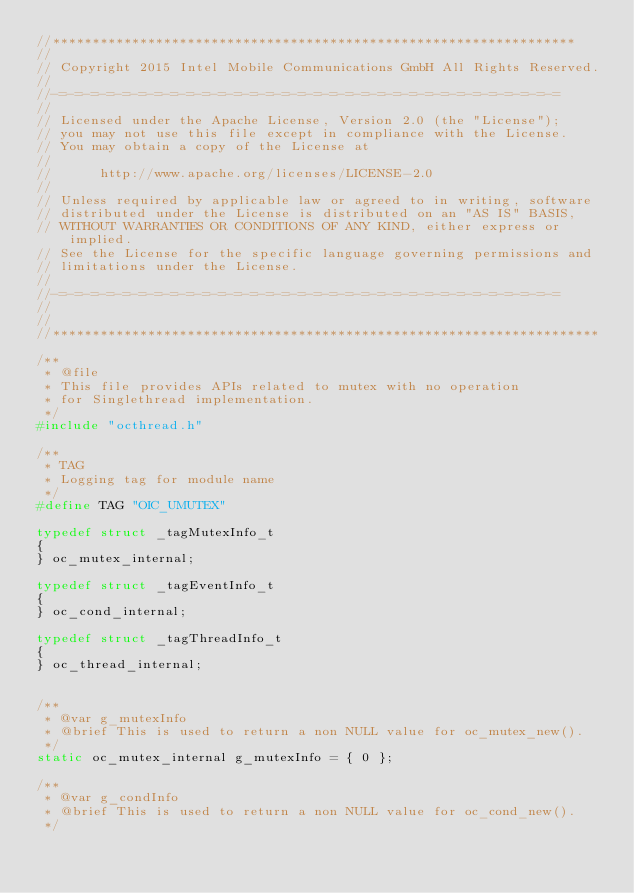Convert code to text. <code><loc_0><loc_0><loc_500><loc_500><_C_>//******************************************************************
//
// Copyright 2015 Intel Mobile Communications GmbH All Rights Reserved.
//
//-=-=-=-=-=-=-=-=-=-=-=-=-=-=-=-=-=-=-=-=-=-=-=-=-=-=-=-=-=-=-=-=
//
// Licensed under the Apache License, Version 2.0 (the "License");
// you may not use this file except in compliance with the License.
// You may obtain a copy of the License at
//
//      http://www.apache.org/licenses/LICENSE-2.0
//
// Unless required by applicable law or agreed to in writing, software
// distributed under the License is distributed on an "AS IS" BASIS,
// WITHOUT WARRANTIES OR CONDITIONS OF ANY KIND, either express or implied.
// See the License for the specific language governing permissions and
// limitations under the License.
//
//-=-=-=-=-=-=-=-=-=-=-=-=-=-=-=-=-=-=-=-=-=-=-=-=-=-=-=-=-=-=-=-=
//
//
//*********************************************************************

/**
 * @file
 * This file provides APIs related to mutex with no operation
 * for Singlethread implementation.
 */
#include "octhread.h"

/**
 * TAG
 * Logging tag for module name
 */
#define TAG "OIC_UMUTEX"

typedef struct _tagMutexInfo_t
{
} oc_mutex_internal;

typedef struct _tagEventInfo_t
{
} oc_cond_internal;

typedef struct _tagThreadInfo_t
{
} oc_thread_internal;


/**
 * @var g_mutexInfo
 * @brief This is used to return a non NULL value for oc_mutex_new().
 */
static oc_mutex_internal g_mutexInfo = { 0 };

/**
 * @var g_condInfo
 * @brief This is used to return a non NULL value for oc_cond_new().
 */</code> 